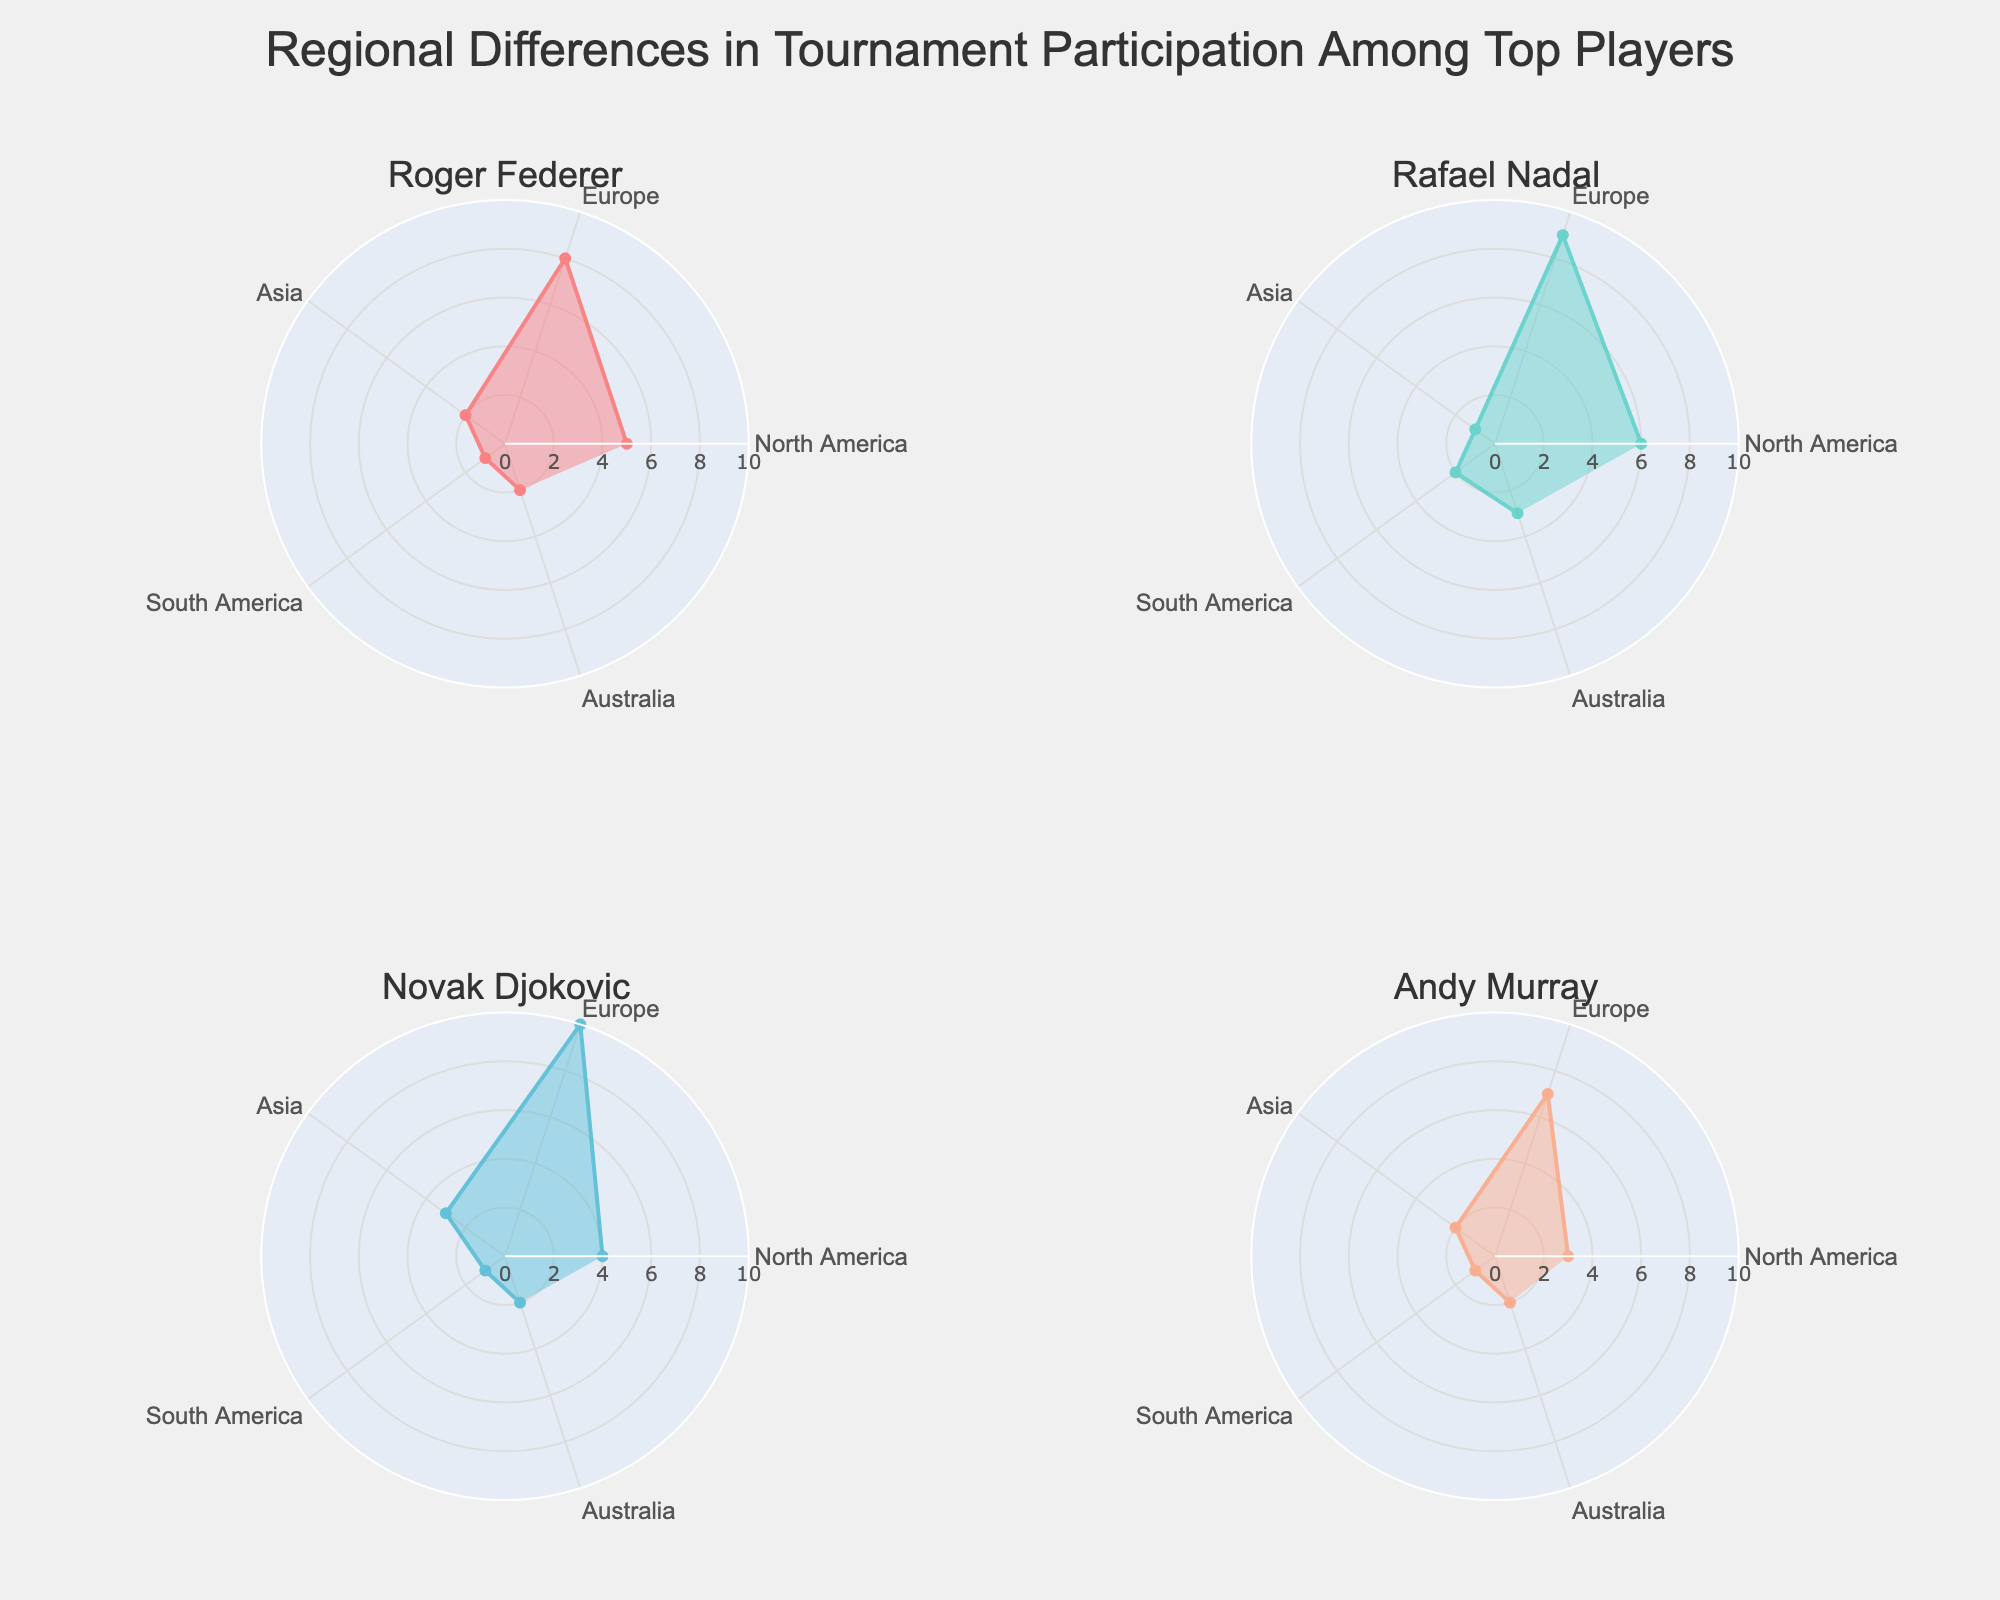What's the title of the figure? The title of the figure is placed at the top center of the chart area which provides a summary of the overall content. It can be read from the plot directly.
Answer: Regional Differences in Tournament Participation Among Top Players Which player has the highest participation frequency in Europe? By listing the players in each subplot and checking their participation frequency values, we can see that Novak Djokovic has the highest participation frequency value in Europe with a frequency of 10.
Answer: Novak Djokovic How many regions are included in the plot? The areas of the polar chart are divided to show participation in different regions. By counting these sections, we can determine the number of regions included.
Answer: 5 What's the total participation frequency for Andy Murray in all regions? By summing the participation frequency values for Andy Murray across the five regions: 3 (North America) + 7 (Europe) + 2 (Asia) + 1 (South America) + 2 (Australia), the total frequency can be calculated.
Answer: 15 Which player has the lowest participation frequency in Asia? By comparing the participation frequencies of all players in Asia, Rafael Nadal has the lowest value, which is 1.
Answer: Rafael Nadal Is the participation frequency of Roger Federer in North America higher or lower than in Europe? By comparing Roger Federer's participation frequency in the two regions: 5 in North America and 8 in Europe, it can be determined that he has a lower participation frequency in North America.
Answer: Lower Who has the most balanced regional participation frequency across all players? To find the player with the most balanced participation, examine the range and variability of participations across regions. Andy Murray has the least variation, with participation frequencies ranging from 1 to 7 across regions.
Answer: Andy Murray What's the average participation frequency for Rafael Nadal across all regions? Sum Rafael Nadal's participation frequencies across all regions, then divide by the number of regions. Calculation: (6 + 9 + 1 + 2 + 3) / 5 = 21 / 5 = 4.2
Answer: 4.2 